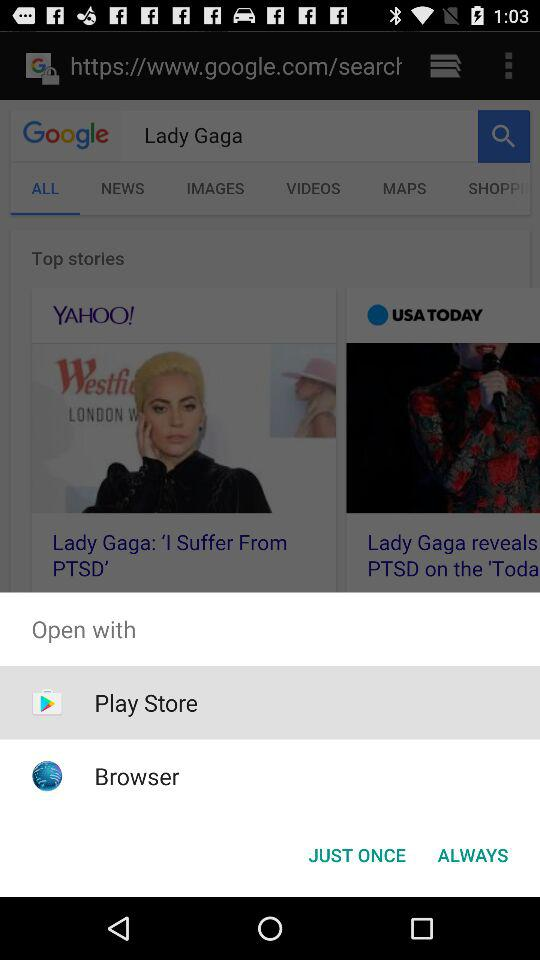What is the search engine? The search engine is "Google". 